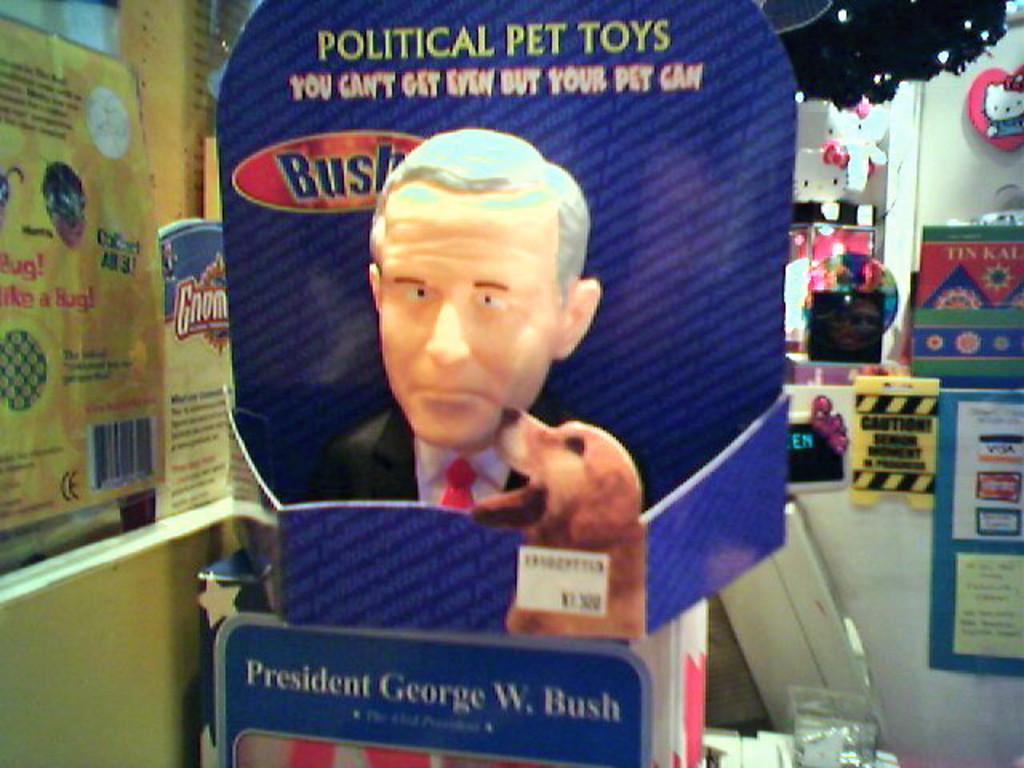How would you summarize this image in a sentence or two? In this picture we can see board on which we can see a person statue and dog. On the left we can see posters and papers attached on the wall. On the right we can see balloons, banners, board and other objects. 